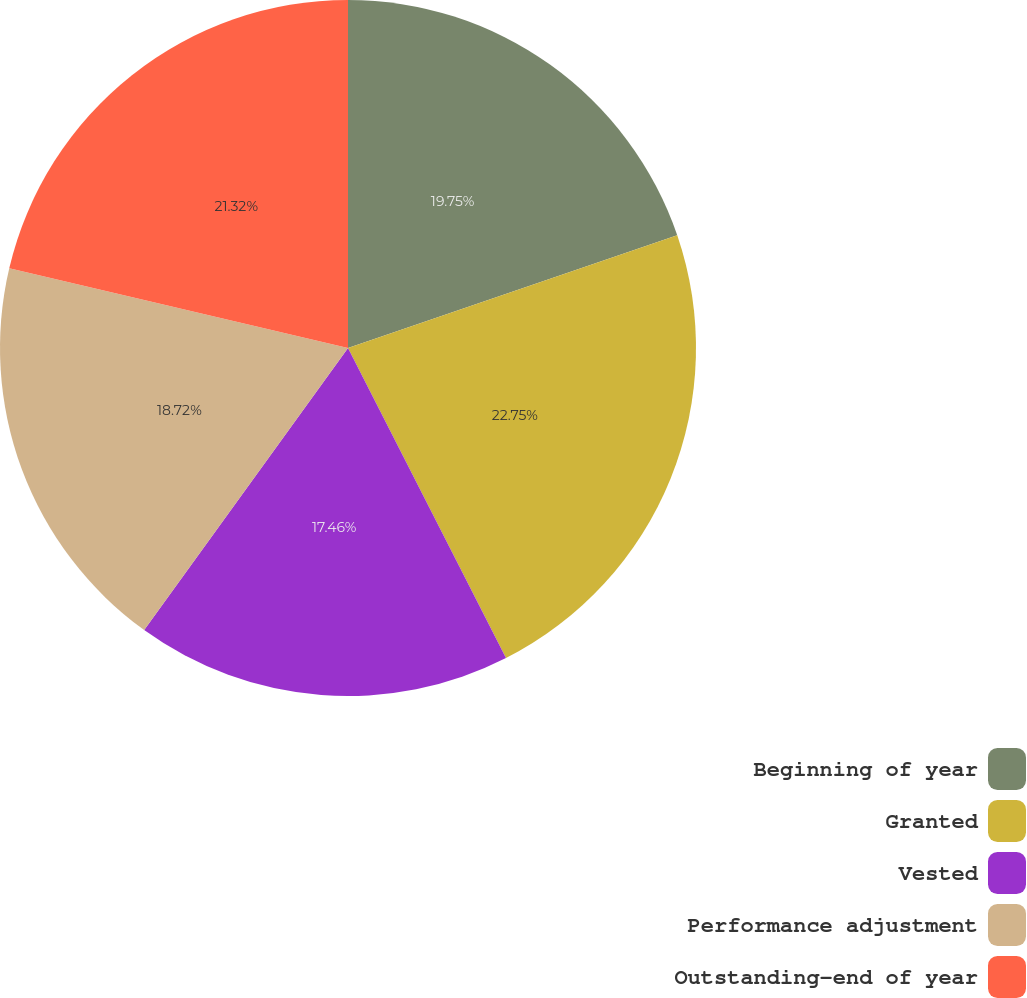Convert chart to OTSL. <chart><loc_0><loc_0><loc_500><loc_500><pie_chart><fcel>Beginning of year<fcel>Granted<fcel>Vested<fcel>Performance adjustment<fcel>Outstanding-end of year<nl><fcel>19.75%<fcel>22.75%<fcel>17.46%<fcel>18.72%<fcel>21.32%<nl></chart> 